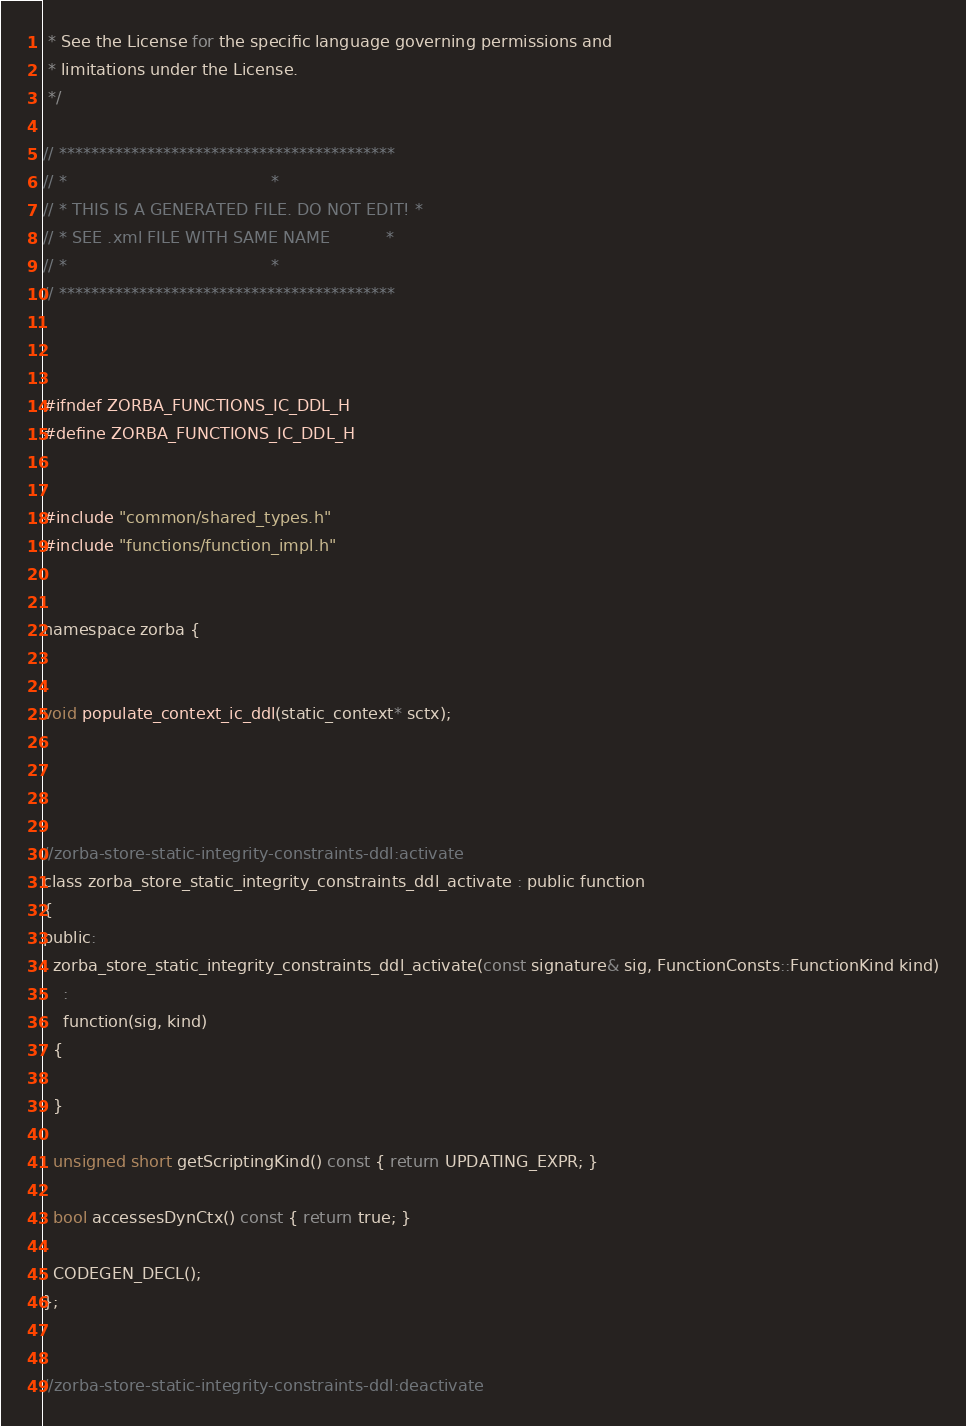Convert code to text. <code><loc_0><loc_0><loc_500><loc_500><_C_> * See the License for the specific language governing permissions and
 * limitations under the License.
 */
 
// ******************************************
// *                                        *
// * THIS IS A GENERATED FILE. DO NOT EDIT! *
// * SEE .xml FILE WITH SAME NAME           *
// *                                        *
// ******************************************



#ifndef ZORBA_FUNCTIONS_IC_DDL_H
#define ZORBA_FUNCTIONS_IC_DDL_H


#include "common/shared_types.h"
#include "functions/function_impl.h"


namespace zorba {


void populate_context_ic_ddl(static_context* sctx);




//zorba-store-static-integrity-constraints-ddl:activate
class zorba_store_static_integrity_constraints_ddl_activate : public function
{
public:
  zorba_store_static_integrity_constraints_ddl_activate(const signature& sig, FunctionConsts::FunctionKind kind)
    : 
    function(sig, kind)
  {

  }

  unsigned short getScriptingKind() const { return UPDATING_EXPR; }

  bool accessesDynCtx() const { return true; }

  CODEGEN_DECL();
};


//zorba-store-static-integrity-constraints-ddl:deactivate</code> 